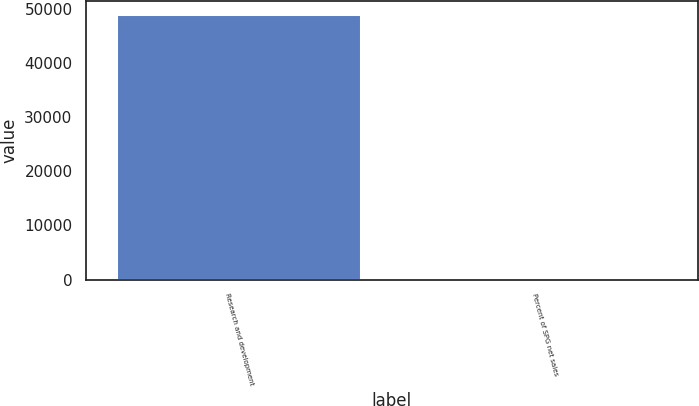<chart> <loc_0><loc_0><loc_500><loc_500><bar_chart><fcel>Research and development<fcel>Percent of SPG net sales<nl><fcel>48959<fcel>6.4<nl></chart> 